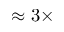<formula> <loc_0><loc_0><loc_500><loc_500>\approx 3 \times</formula> 